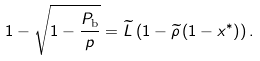<formula> <loc_0><loc_0><loc_500><loc_500>1 - \sqrt { 1 - \frac { P _ { \text {b} } } { p } } = \widetilde { L } \left ( 1 - \widetilde { \rho } \left ( 1 - x ^ { * } \right ) \right ) .</formula> 